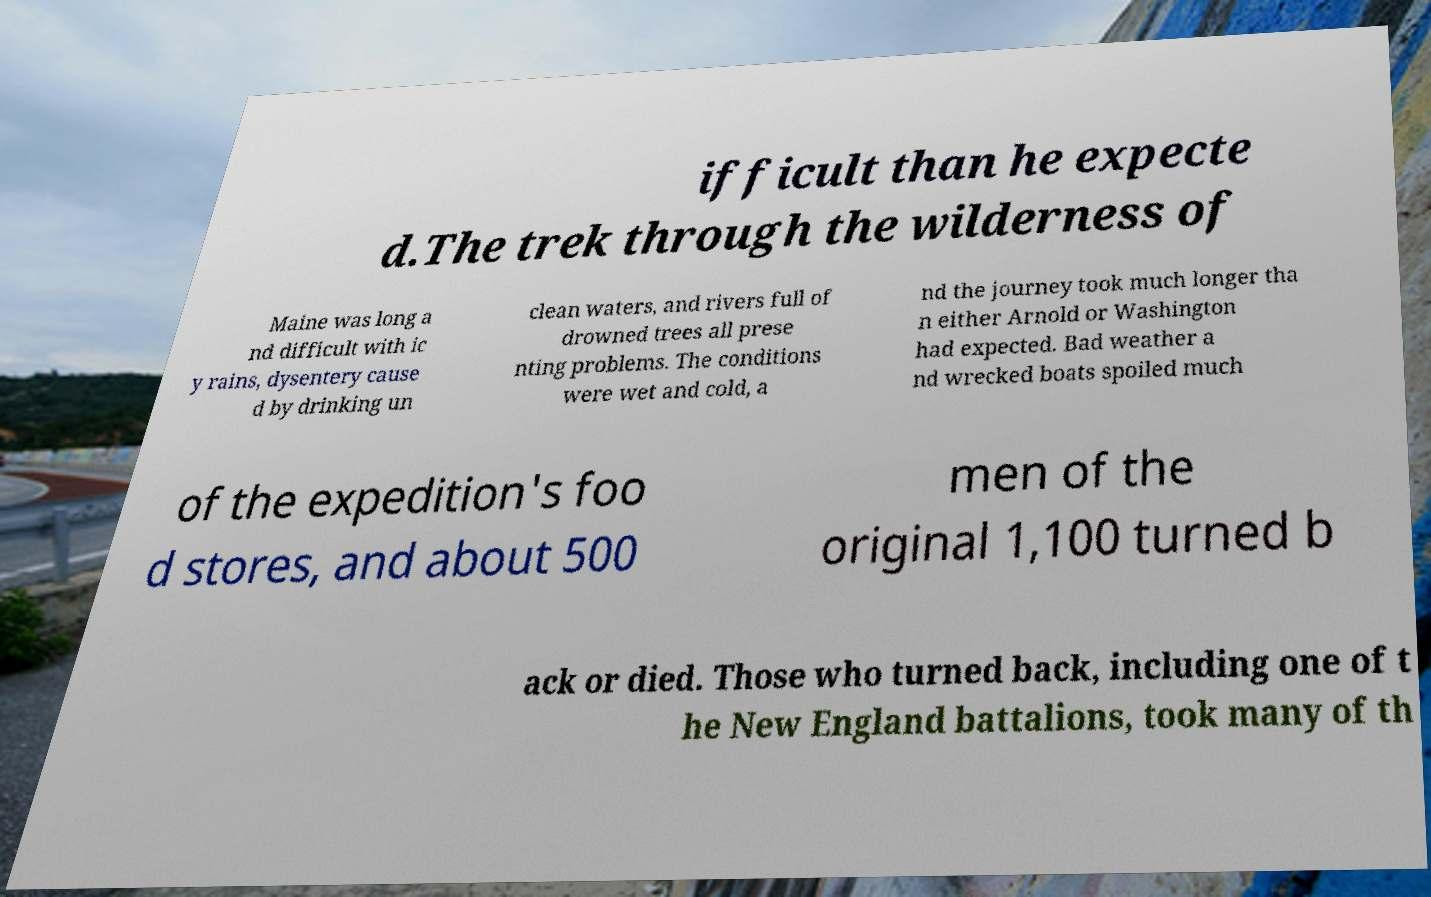Can you accurately transcribe the text from the provided image for me? ifficult than he expecte d.The trek through the wilderness of Maine was long a nd difficult with ic y rains, dysentery cause d by drinking un clean waters, and rivers full of drowned trees all prese nting problems. The conditions were wet and cold, a nd the journey took much longer tha n either Arnold or Washington had expected. Bad weather a nd wrecked boats spoiled much of the expedition's foo d stores, and about 500 men of the original 1,100 turned b ack or died. Those who turned back, including one of t he New England battalions, took many of th 